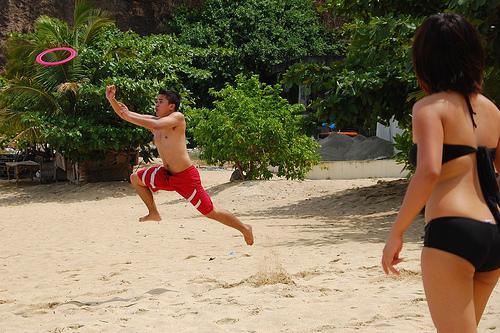What sport are they playing?
Give a very brief answer. Frisbee. Are they on a beach?
Short answer required. Yes. Is the boy barefooted?
Short answer required. Yes. 